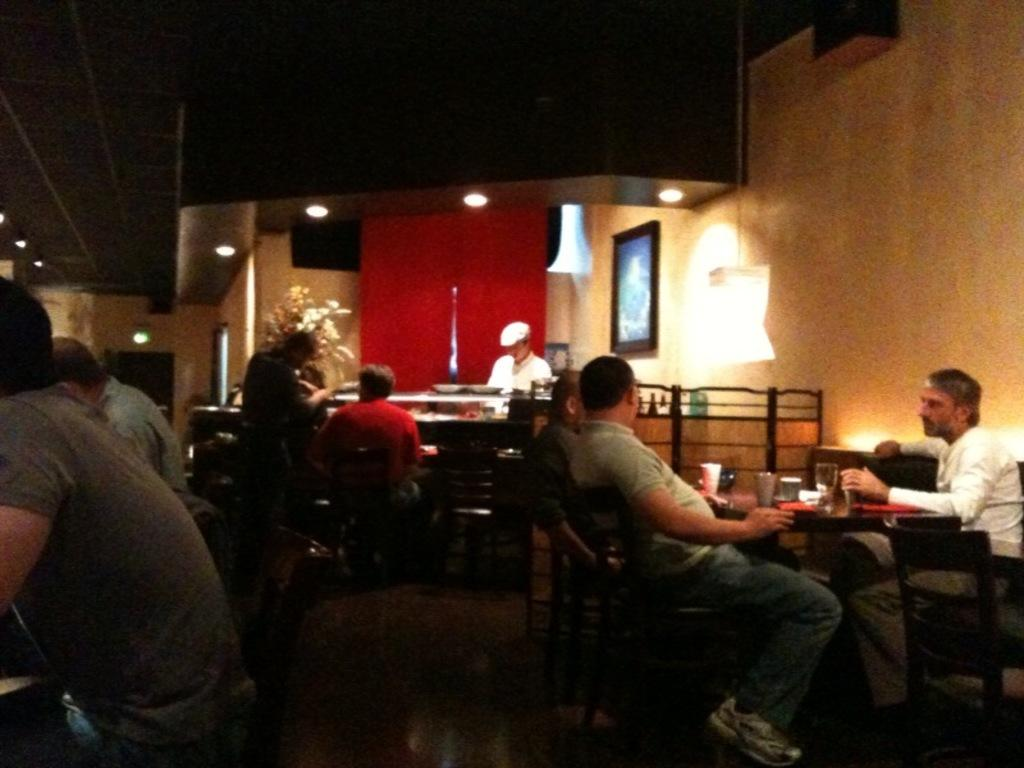What are the people in the image doing? There is a group of people sitting in chairs in the image. What objects can be seen on the table? There are glasses on the table in the image. What can be seen in the background of the image? There is a lamp, a light, a frame, and a plant in the background of the image. Is there anyone near the table? Yes, there is a person near the table in the image. What type of brush is being used by the person near the table? There is no brush visible in the image; the person near the table is not using any brush. 